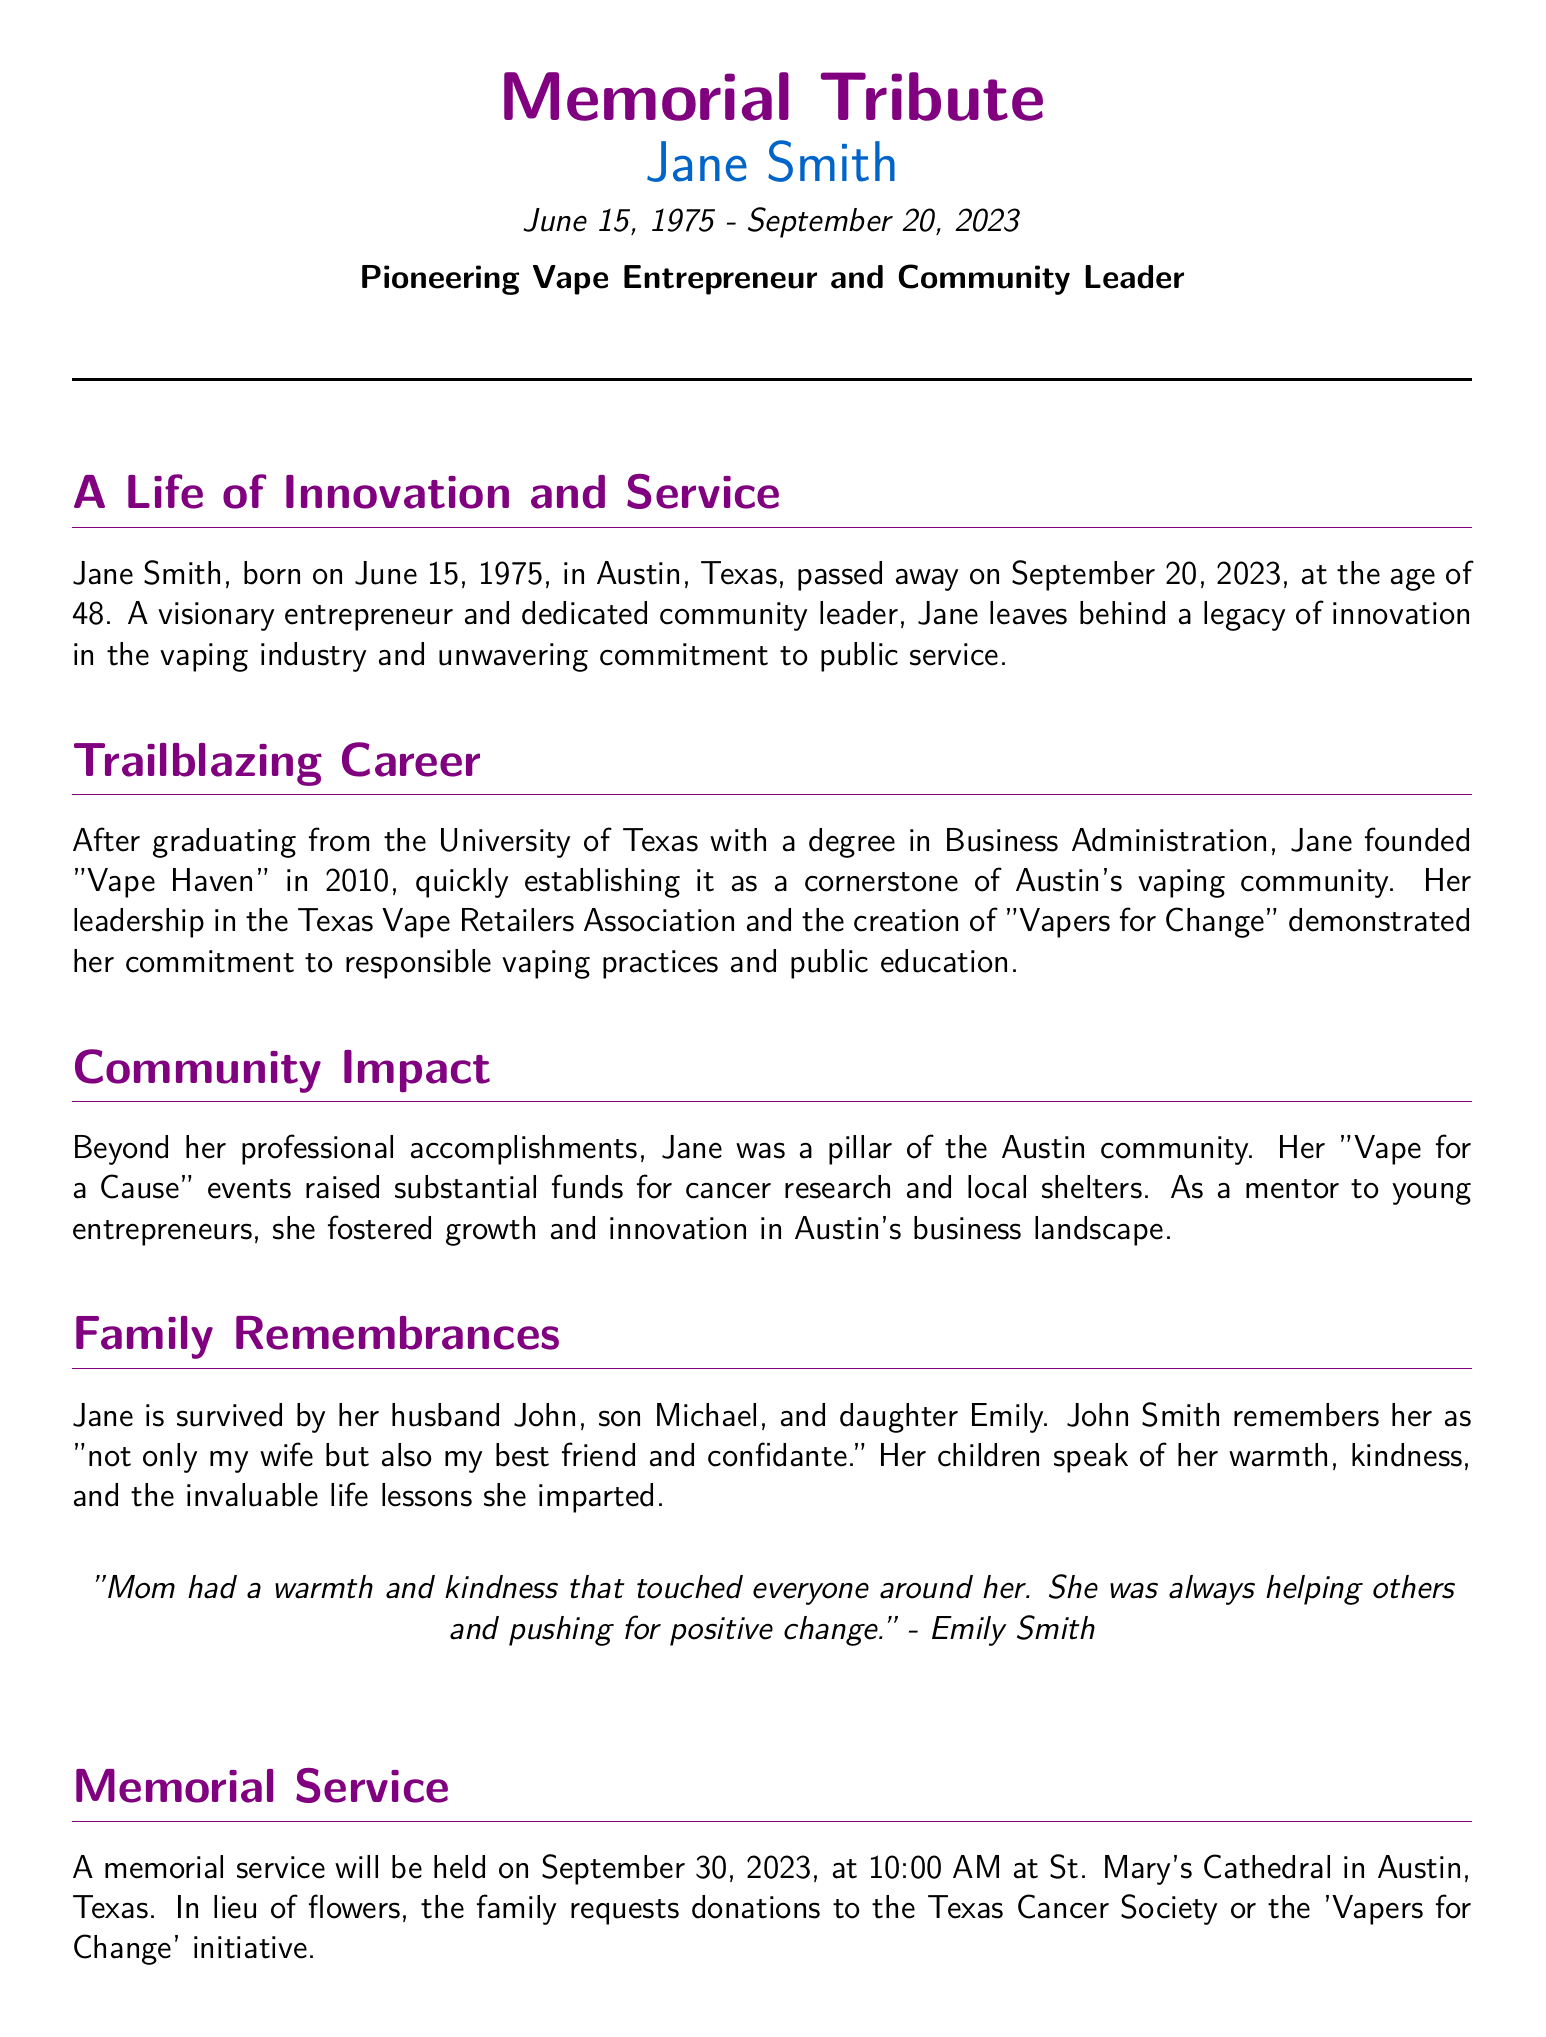what is Jane Smith’s date of birth? Jane Smith was born on June 15, 1975.
Answer: June 15, 1975 what is the name of Jane's husband? The document states that Jane is survived by her husband John.
Answer: John which organization did Jane found in 2010? She founded "Vape Haven" in 2010.
Answer: Vape Haven what was the date of the memorial service? The memorial service will be held on September 30, 2023.
Answer: September 30, 2023 what initiative did Jane create focused on responsible vaping practices? Jane created "Vapers for Change".
Answer: Vapers for Change how old was Jane at the time of her passing? Jane passed away at the age of 48.
Answer: 48 what type of events did Jane organize to raise funds? Jane organized "Vape for a Cause" events.
Answer: Vape for a Cause what does Emily Smith say about her mother? Emily Smith mentions her mother's warmth and kindness.
Answer: warmth and kindness who remembers Jane as "my best friend and confidante"? Her husband John remembers her this way.
Answer: John Smith 